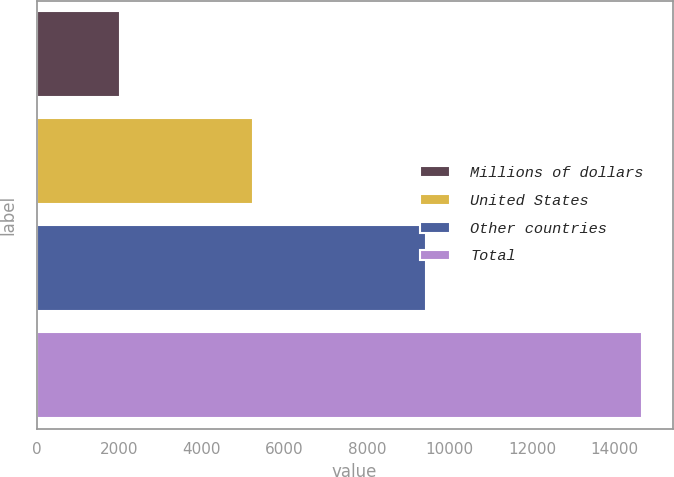<chart> <loc_0><loc_0><loc_500><loc_500><bar_chart><fcel>Millions of dollars<fcel>United States<fcel>Other countries<fcel>Total<nl><fcel>2009<fcel>5248<fcel>9427<fcel>14675<nl></chart> 